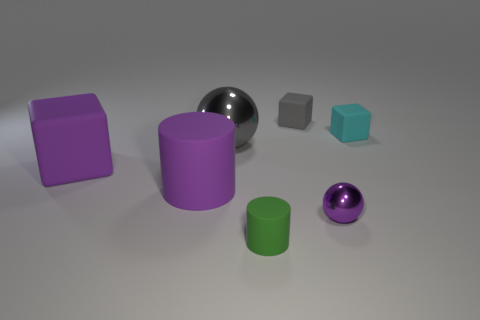Add 3 cyan matte blocks. How many objects exist? 10 Subtract all cylinders. How many objects are left? 5 Subtract all purple matte balls. Subtract all large balls. How many objects are left? 6 Add 1 big gray things. How many big gray things are left? 2 Add 2 big gray shiny cubes. How many big gray shiny cubes exist? 2 Subtract 0 red cylinders. How many objects are left? 7 